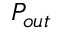<formula> <loc_0><loc_0><loc_500><loc_500>P _ { o u t }</formula> 